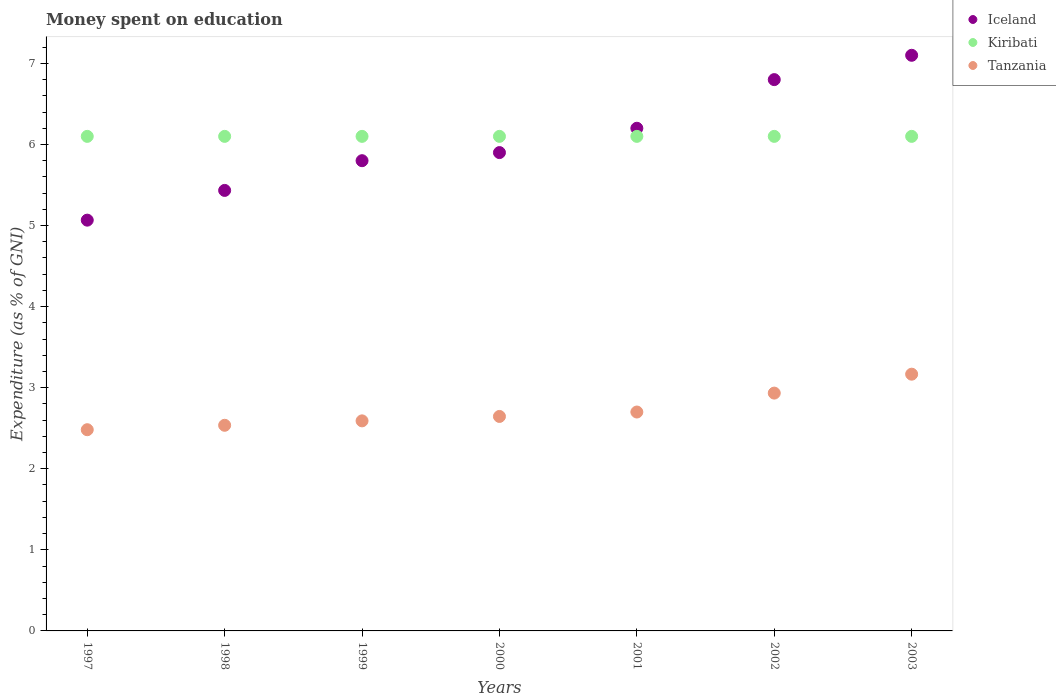How many different coloured dotlines are there?
Provide a succinct answer. 3. Is the number of dotlines equal to the number of legend labels?
Keep it short and to the point. Yes. Across all years, what is the maximum amount of money spent on education in Kiribati?
Offer a very short reply. 6.1. Across all years, what is the minimum amount of money spent on education in Tanzania?
Provide a short and direct response. 2.48. In which year was the amount of money spent on education in Kiribati maximum?
Provide a succinct answer. 1997. In which year was the amount of money spent on education in Kiribati minimum?
Ensure brevity in your answer.  1997. What is the total amount of money spent on education in Iceland in the graph?
Keep it short and to the point. 42.3. What is the difference between the amount of money spent on education in Tanzania in 1997 and that in 2001?
Make the answer very short. -0.22. What is the difference between the amount of money spent on education in Kiribati in 1998 and the amount of money spent on education in Tanzania in 2002?
Keep it short and to the point. 3.17. What is the average amount of money spent on education in Kiribati per year?
Make the answer very short. 6.1. In the year 2001, what is the difference between the amount of money spent on education in Kiribati and amount of money spent on education in Iceland?
Make the answer very short. -0.1. In how many years, is the amount of money spent on education in Tanzania greater than 1.4 %?
Provide a short and direct response. 7. What is the ratio of the amount of money spent on education in Iceland in 1998 to that in 2002?
Provide a short and direct response. 0.8. What is the difference between the highest and the second highest amount of money spent on education in Iceland?
Offer a terse response. 0.3. What is the difference between the highest and the lowest amount of money spent on education in Iceland?
Ensure brevity in your answer.  2.03. Is the sum of the amount of money spent on education in Iceland in 1998 and 2003 greater than the maximum amount of money spent on education in Kiribati across all years?
Offer a very short reply. Yes. Is it the case that in every year, the sum of the amount of money spent on education in Iceland and amount of money spent on education in Kiribati  is greater than the amount of money spent on education in Tanzania?
Ensure brevity in your answer.  Yes. How many dotlines are there?
Your response must be concise. 3. Does the graph contain any zero values?
Offer a very short reply. No. Does the graph contain grids?
Give a very brief answer. No. Where does the legend appear in the graph?
Your response must be concise. Top right. How are the legend labels stacked?
Provide a succinct answer. Vertical. What is the title of the graph?
Keep it short and to the point. Money spent on education. What is the label or title of the X-axis?
Keep it short and to the point. Years. What is the label or title of the Y-axis?
Your response must be concise. Expenditure (as % of GNI). What is the Expenditure (as % of GNI) of Iceland in 1997?
Make the answer very short. 5.07. What is the Expenditure (as % of GNI) of Kiribati in 1997?
Provide a short and direct response. 6.1. What is the Expenditure (as % of GNI) of Tanzania in 1997?
Provide a short and direct response. 2.48. What is the Expenditure (as % of GNI) in Iceland in 1998?
Offer a very short reply. 5.43. What is the Expenditure (as % of GNI) in Tanzania in 1998?
Keep it short and to the point. 2.54. What is the Expenditure (as % of GNI) of Kiribati in 1999?
Keep it short and to the point. 6.1. What is the Expenditure (as % of GNI) in Tanzania in 1999?
Ensure brevity in your answer.  2.59. What is the Expenditure (as % of GNI) in Kiribati in 2000?
Offer a very short reply. 6.1. What is the Expenditure (as % of GNI) in Tanzania in 2000?
Ensure brevity in your answer.  2.65. What is the Expenditure (as % of GNI) in Tanzania in 2001?
Your response must be concise. 2.7. What is the Expenditure (as % of GNI) in Iceland in 2002?
Keep it short and to the point. 6.8. What is the Expenditure (as % of GNI) of Kiribati in 2002?
Give a very brief answer. 6.1. What is the Expenditure (as % of GNI) of Tanzania in 2002?
Ensure brevity in your answer.  2.93. What is the Expenditure (as % of GNI) in Iceland in 2003?
Make the answer very short. 7.1. What is the Expenditure (as % of GNI) of Kiribati in 2003?
Keep it short and to the point. 6.1. What is the Expenditure (as % of GNI) of Tanzania in 2003?
Give a very brief answer. 3.17. Across all years, what is the maximum Expenditure (as % of GNI) in Iceland?
Keep it short and to the point. 7.1. Across all years, what is the maximum Expenditure (as % of GNI) in Kiribati?
Give a very brief answer. 6.1. Across all years, what is the maximum Expenditure (as % of GNI) in Tanzania?
Provide a short and direct response. 3.17. Across all years, what is the minimum Expenditure (as % of GNI) of Iceland?
Give a very brief answer. 5.07. Across all years, what is the minimum Expenditure (as % of GNI) of Kiribati?
Keep it short and to the point. 6.1. Across all years, what is the minimum Expenditure (as % of GNI) in Tanzania?
Offer a terse response. 2.48. What is the total Expenditure (as % of GNI) of Iceland in the graph?
Keep it short and to the point. 42.3. What is the total Expenditure (as % of GNI) in Kiribati in the graph?
Keep it short and to the point. 42.7. What is the total Expenditure (as % of GNI) in Tanzania in the graph?
Make the answer very short. 19.05. What is the difference between the Expenditure (as % of GNI) of Iceland in 1997 and that in 1998?
Provide a succinct answer. -0.37. What is the difference between the Expenditure (as % of GNI) of Kiribati in 1997 and that in 1998?
Offer a terse response. 0. What is the difference between the Expenditure (as % of GNI) in Tanzania in 1997 and that in 1998?
Ensure brevity in your answer.  -0.05. What is the difference between the Expenditure (as % of GNI) of Iceland in 1997 and that in 1999?
Your response must be concise. -0.73. What is the difference between the Expenditure (as % of GNI) in Kiribati in 1997 and that in 1999?
Your answer should be very brief. 0. What is the difference between the Expenditure (as % of GNI) in Tanzania in 1997 and that in 1999?
Ensure brevity in your answer.  -0.11. What is the difference between the Expenditure (as % of GNI) of Iceland in 1997 and that in 2000?
Offer a very short reply. -0.83. What is the difference between the Expenditure (as % of GNI) in Tanzania in 1997 and that in 2000?
Offer a terse response. -0.16. What is the difference between the Expenditure (as % of GNI) in Iceland in 1997 and that in 2001?
Your response must be concise. -1.13. What is the difference between the Expenditure (as % of GNI) in Tanzania in 1997 and that in 2001?
Give a very brief answer. -0.22. What is the difference between the Expenditure (as % of GNI) of Iceland in 1997 and that in 2002?
Make the answer very short. -1.73. What is the difference between the Expenditure (as % of GNI) of Kiribati in 1997 and that in 2002?
Your response must be concise. 0. What is the difference between the Expenditure (as % of GNI) in Tanzania in 1997 and that in 2002?
Keep it short and to the point. -0.45. What is the difference between the Expenditure (as % of GNI) in Iceland in 1997 and that in 2003?
Your answer should be very brief. -2.03. What is the difference between the Expenditure (as % of GNI) in Tanzania in 1997 and that in 2003?
Your answer should be compact. -0.68. What is the difference between the Expenditure (as % of GNI) of Iceland in 1998 and that in 1999?
Offer a terse response. -0.37. What is the difference between the Expenditure (as % of GNI) in Tanzania in 1998 and that in 1999?
Your response must be concise. -0.05. What is the difference between the Expenditure (as % of GNI) in Iceland in 1998 and that in 2000?
Provide a succinct answer. -0.47. What is the difference between the Expenditure (as % of GNI) in Kiribati in 1998 and that in 2000?
Ensure brevity in your answer.  0. What is the difference between the Expenditure (as % of GNI) of Tanzania in 1998 and that in 2000?
Provide a short and direct response. -0.11. What is the difference between the Expenditure (as % of GNI) in Iceland in 1998 and that in 2001?
Make the answer very short. -0.77. What is the difference between the Expenditure (as % of GNI) of Kiribati in 1998 and that in 2001?
Offer a very short reply. 0. What is the difference between the Expenditure (as % of GNI) in Tanzania in 1998 and that in 2001?
Your response must be concise. -0.16. What is the difference between the Expenditure (as % of GNI) in Iceland in 1998 and that in 2002?
Your response must be concise. -1.37. What is the difference between the Expenditure (as % of GNI) in Kiribati in 1998 and that in 2002?
Offer a very short reply. 0. What is the difference between the Expenditure (as % of GNI) in Tanzania in 1998 and that in 2002?
Keep it short and to the point. -0.4. What is the difference between the Expenditure (as % of GNI) of Iceland in 1998 and that in 2003?
Your answer should be compact. -1.67. What is the difference between the Expenditure (as % of GNI) of Kiribati in 1998 and that in 2003?
Ensure brevity in your answer.  0. What is the difference between the Expenditure (as % of GNI) of Tanzania in 1998 and that in 2003?
Keep it short and to the point. -0.63. What is the difference between the Expenditure (as % of GNI) in Iceland in 1999 and that in 2000?
Make the answer very short. -0.1. What is the difference between the Expenditure (as % of GNI) in Tanzania in 1999 and that in 2000?
Provide a short and direct response. -0.05. What is the difference between the Expenditure (as % of GNI) of Iceland in 1999 and that in 2001?
Give a very brief answer. -0.4. What is the difference between the Expenditure (as % of GNI) of Kiribati in 1999 and that in 2001?
Provide a short and direct response. 0. What is the difference between the Expenditure (as % of GNI) in Tanzania in 1999 and that in 2001?
Your answer should be compact. -0.11. What is the difference between the Expenditure (as % of GNI) of Iceland in 1999 and that in 2002?
Your response must be concise. -1. What is the difference between the Expenditure (as % of GNI) in Tanzania in 1999 and that in 2002?
Provide a short and direct response. -0.34. What is the difference between the Expenditure (as % of GNI) in Tanzania in 1999 and that in 2003?
Offer a terse response. -0.58. What is the difference between the Expenditure (as % of GNI) of Iceland in 2000 and that in 2001?
Your answer should be very brief. -0.3. What is the difference between the Expenditure (as % of GNI) in Kiribati in 2000 and that in 2001?
Give a very brief answer. 0. What is the difference between the Expenditure (as % of GNI) of Tanzania in 2000 and that in 2001?
Give a very brief answer. -0.05. What is the difference between the Expenditure (as % of GNI) in Kiribati in 2000 and that in 2002?
Keep it short and to the point. 0. What is the difference between the Expenditure (as % of GNI) in Tanzania in 2000 and that in 2002?
Your answer should be very brief. -0.29. What is the difference between the Expenditure (as % of GNI) in Kiribati in 2000 and that in 2003?
Give a very brief answer. 0. What is the difference between the Expenditure (as % of GNI) of Tanzania in 2000 and that in 2003?
Make the answer very short. -0.52. What is the difference between the Expenditure (as % of GNI) in Kiribati in 2001 and that in 2002?
Your answer should be compact. 0. What is the difference between the Expenditure (as % of GNI) in Tanzania in 2001 and that in 2002?
Keep it short and to the point. -0.23. What is the difference between the Expenditure (as % of GNI) in Iceland in 2001 and that in 2003?
Offer a very short reply. -0.9. What is the difference between the Expenditure (as % of GNI) in Tanzania in 2001 and that in 2003?
Provide a succinct answer. -0.47. What is the difference between the Expenditure (as % of GNI) in Kiribati in 2002 and that in 2003?
Keep it short and to the point. 0. What is the difference between the Expenditure (as % of GNI) of Tanzania in 2002 and that in 2003?
Give a very brief answer. -0.23. What is the difference between the Expenditure (as % of GNI) in Iceland in 1997 and the Expenditure (as % of GNI) in Kiribati in 1998?
Make the answer very short. -1.03. What is the difference between the Expenditure (as % of GNI) of Iceland in 1997 and the Expenditure (as % of GNI) of Tanzania in 1998?
Offer a terse response. 2.53. What is the difference between the Expenditure (as % of GNI) in Kiribati in 1997 and the Expenditure (as % of GNI) in Tanzania in 1998?
Offer a very short reply. 3.56. What is the difference between the Expenditure (as % of GNI) of Iceland in 1997 and the Expenditure (as % of GNI) of Kiribati in 1999?
Ensure brevity in your answer.  -1.03. What is the difference between the Expenditure (as % of GNI) of Iceland in 1997 and the Expenditure (as % of GNI) of Tanzania in 1999?
Ensure brevity in your answer.  2.48. What is the difference between the Expenditure (as % of GNI) of Kiribati in 1997 and the Expenditure (as % of GNI) of Tanzania in 1999?
Keep it short and to the point. 3.51. What is the difference between the Expenditure (as % of GNI) of Iceland in 1997 and the Expenditure (as % of GNI) of Kiribati in 2000?
Provide a succinct answer. -1.03. What is the difference between the Expenditure (as % of GNI) of Iceland in 1997 and the Expenditure (as % of GNI) of Tanzania in 2000?
Keep it short and to the point. 2.42. What is the difference between the Expenditure (as % of GNI) of Kiribati in 1997 and the Expenditure (as % of GNI) of Tanzania in 2000?
Give a very brief answer. 3.45. What is the difference between the Expenditure (as % of GNI) in Iceland in 1997 and the Expenditure (as % of GNI) in Kiribati in 2001?
Your answer should be very brief. -1.03. What is the difference between the Expenditure (as % of GNI) of Iceland in 1997 and the Expenditure (as % of GNI) of Tanzania in 2001?
Ensure brevity in your answer.  2.37. What is the difference between the Expenditure (as % of GNI) in Kiribati in 1997 and the Expenditure (as % of GNI) in Tanzania in 2001?
Give a very brief answer. 3.4. What is the difference between the Expenditure (as % of GNI) in Iceland in 1997 and the Expenditure (as % of GNI) in Kiribati in 2002?
Give a very brief answer. -1.03. What is the difference between the Expenditure (as % of GNI) in Iceland in 1997 and the Expenditure (as % of GNI) in Tanzania in 2002?
Keep it short and to the point. 2.13. What is the difference between the Expenditure (as % of GNI) in Kiribati in 1997 and the Expenditure (as % of GNI) in Tanzania in 2002?
Provide a short and direct response. 3.17. What is the difference between the Expenditure (as % of GNI) in Iceland in 1997 and the Expenditure (as % of GNI) in Kiribati in 2003?
Keep it short and to the point. -1.03. What is the difference between the Expenditure (as % of GNI) in Kiribati in 1997 and the Expenditure (as % of GNI) in Tanzania in 2003?
Ensure brevity in your answer.  2.93. What is the difference between the Expenditure (as % of GNI) of Iceland in 1998 and the Expenditure (as % of GNI) of Kiribati in 1999?
Offer a very short reply. -0.67. What is the difference between the Expenditure (as % of GNI) of Iceland in 1998 and the Expenditure (as % of GNI) of Tanzania in 1999?
Offer a very short reply. 2.84. What is the difference between the Expenditure (as % of GNI) of Kiribati in 1998 and the Expenditure (as % of GNI) of Tanzania in 1999?
Make the answer very short. 3.51. What is the difference between the Expenditure (as % of GNI) in Iceland in 1998 and the Expenditure (as % of GNI) in Tanzania in 2000?
Ensure brevity in your answer.  2.79. What is the difference between the Expenditure (as % of GNI) in Kiribati in 1998 and the Expenditure (as % of GNI) in Tanzania in 2000?
Your answer should be very brief. 3.45. What is the difference between the Expenditure (as % of GNI) of Iceland in 1998 and the Expenditure (as % of GNI) of Tanzania in 2001?
Your response must be concise. 2.73. What is the difference between the Expenditure (as % of GNI) of Kiribati in 1998 and the Expenditure (as % of GNI) of Tanzania in 2001?
Ensure brevity in your answer.  3.4. What is the difference between the Expenditure (as % of GNI) of Iceland in 1998 and the Expenditure (as % of GNI) of Kiribati in 2002?
Provide a short and direct response. -0.67. What is the difference between the Expenditure (as % of GNI) of Iceland in 1998 and the Expenditure (as % of GNI) of Tanzania in 2002?
Offer a terse response. 2.5. What is the difference between the Expenditure (as % of GNI) of Kiribati in 1998 and the Expenditure (as % of GNI) of Tanzania in 2002?
Your answer should be compact. 3.17. What is the difference between the Expenditure (as % of GNI) of Iceland in 1998 and the Expenditure (as % of GNI) of Kiribati in 2003?
Give a very brief answer. -0.67. What is the difference between the Expenditure (as % of GNI) in Iceland in 1998 and the Expenditure (as % of GNI) in Tanzania in 2003?
Keep it short and to the point. 2.27. What is the difference between the Expenditure (as % of GNI) of Kiribati in 1998 and the Expenditure (as % of GNI) of Tanzania in 2003?
Provide a succinct answer. 2.93. What is the difference between the Expenditure (as % of GNI) of Iceland in 1999 and the Expenditure (as % of GNI) of Tanzania in 2000?
Your response must be concise. 3.15. What is the difference between the Expenditure (as % of GNI) of Kiribati in 1999 and the Expenditure (as % of GNI) of Tanzania in 2000?
Offer a very short reply. 3.45. What is the difference between the Expenditure (as % of GNI) of Iceland in 1999 and the Expenditure (as % of GNI) of Kiribati in 2002?
Your answer should be compact. -0.3. What is the difference between the Expenditure (as % of GNI) of Iceland in 1999 and the Expenditure (as % of GNI) of Tanzania in 2002?
Give a very brief answer. 2.87. What is the difference between the Expenditure (as % of GNI) of Kiribati in 1999 and the Expenditure (as % of GNI) of Tanzania in 2002?
Your answer should be compact. 3.17. What is the difference between the Expenditure (as % of GNI) in Iceland in 1999 and the Expenditure (as % of GNI) in Tanzania in 2003?
Offer a terse response. 2.63. What is the difference between the Expenditure (as % of GNI) of Kiribati in 1999 and the Expenditure (as % of GNI) of Tanzania in 2003?
Your answer should be very brief. 2.93. What is the difference between the Expenditure (as % of GNI) in Iceland in 2000 and the Expenditure (as % of GNI) in Kiribati in 2001?
Your answer should be very brief. -0.2. What is the difference between the Expenditure (as % of GNI) of Iceland in 2000 and the Expenditure (as % of GNI) of Tanzania in 2001?
Keep it short and to the point. 3.2. What is the difference between the Expenditure (as % of GNI) of Kiribati in 2000 and the Expenditure (as % of GNI) of Tanzania in 2001?
Give a very brief answer. 3.4. What is the difference between the Expenditure (as % of GNI) in Iceland in 2000 and the Expenditure (as % of GNI) in Kiribati in 2002?
Give a very brief answer. -0.2. What is the difference between the Expenditure (as % of GNI) in Iceland in 2000 and the Expenditure (as % of GNI) in Tanzania in 2002?
Give a very brief answer. 2.97. What is the difference between the Expenditure (as % of GNI) in Kiribati in 2000 and the Expenditure (as % of GNI) in Tanzania in 2002?
Offer a terse response. 3.17. What is the difference between the Expenditure (as % of GNI) in Iceland in 2000 and the Expenditure (as % of GNI) in Kiribati in 2003?
Offer a terse response. -0.2. What is the difference between the Expenditure (as % of GNI) in Iceland in 2000 and the Expenditure (as % of GNI) in Tanzania in 2003?
Make the answer very short. 2.73. What is the difference between the Expenditure (as % of GNI) of Kiribati in 2000 and the Expenditure (as % of GNI) of Tanzania in 2003?
Your answer should be very brief. 2.93. What is the difference between the Expenditure (as % of GNI) in Iceland in 2001 and the Expenditure (as % of GNI) in Kiribati in 2002?
Ensure brevity in your answer.  0.1. What is the difference between the Expenditure (as % of GNI) of Iceland in 2001 and the Expenditure (as % of GNI) of Tanzania in 2002?
Offer a terse response. 3.27. What is the difference between the Expenditure (as % of GNI) of Kiribati in 2001 and the Expenditure (as % of GNI) of Tanzania in 2002?
Provide a short and direct response. 3.17. What is the difference between the Expenditure (as % of GNI) in Iceland in 2001 and the Expenditure (as % of GNI) in Kiribati in 2003?
Make the answer very short. 0.1. What is the difference between the Expenditure (as % of GNI) in Iceland in 2001 and the Expenditure (as % of GNI) in Tanzania in 2003?
Ensure brevity in your answer.  3.03. What is the difference between the Expenditure (as % of GNI) in Kiribati in 2001 and the Expenditure (as % of GNI) in Tanzania in 2003?
Make the answer very short. 2.93. What is the difference between the Expenditure (as % of GNI) of Iceland in 2002 and the Expenditure (as % of GNI) of Tanzania in 2003?
Provide a short and direct response. 3.63. What is the difference between the Expenditure (as % of GNI) in Kiribati in 2002 and the Expenditure (as % of GNI) in Tanzania in 2003?
Keep it short and to the point. 2.93. What is the average Expenditure (as % of GNI) in Iceland per year?
Offer a very short reply. 6.04. What is the average Expenditure (as % of GNI) in Kiribati per year?
Make the answer very short. 6.1. What is the average Expenditure (as % of GNI) of Tanzania per year?
Make the answer very short. 2.72. In the year 1997, what is the difference between the Expenditure (as % of GNI) in Iceland and Expenditure (as % of GNI) in Kiribati?
Keep it short and to the point. -1.03. In the year 1997, what is the difference between the Expenditure (as % of GNI) in Iceland and Expenditure (as % of GNI) in Tanzania?
Keep it short and to the point. 2.58. In the year 1997, what is the difference between the Expenditure (as % of GNI) in Kiribati and Expenditure (as % of GNI) in Tanzania?
Keep it short and to the point. 3.62. In the year 1998, what is the difference between the Expenditure (as % of GNI) in Iceland and Expenditure (as % of GNI) in Kiribati?
Make the answer very short. -0.67. In the year 1998, what is the difference between the Expenditure (as % of GNI) of Iceland and Expenditure (as % of GNI) of Tanzania?
Ensure brevity in your answer.  2.9. In the year 1998, what is the difference between the Expenditure (as % of GNI) in Kiribati and Expenditure (as % of GNI) in Tanzania?
Make the answer very short. 3.56. In the year 1999, what is the difference between the Expenditure (as % of GNI) in Iceland and Expenditure (as % of GNI) in Kiribati?
Offer a very short reply. -0.3. In the year 1999, what is the difference between the Expenditure (as % of GNI) of Iceland and Expenditure (as % of GNI) of Tanzania?
Give a very brief answer. 3.21. In the year 1999, what is the difference between the Expenditure (as % of GNI) of Kiribati and Expenditure (as % of GNI) of Tanzania?
Ensure brevity in your answer.  3.51. In the year 2000, what is the difference between the Expenditure (as % of GNI) in Iceland and Expenditure (as % of GNI) in Tanzania?
Provide a short and direct response. 3.25. In the year 2000, what is the difference between the Expenditure (as % of GNI) of Kiribati and Expenditure (as % of GNI) of Tanzania?
Make the answer very short. 3.45. In the year 2001, what is the difference between the Expenditure (as % of GNI) in Iceland and Expenditure (as % of GNI) in Kiribati?
Offer a terse response. 0.1. In the year 2002, what is the difference between the Expenditure (as % of GNI) of Iceland and Expenditure (as % of GNI) of Kiribati?
Your answer should be compact. 0.7. In the year 2002, what is the difference between the Expenditure (as % of GNI) of Iceland and Expenditure (as % of GNI) of Tanzania?
Your answer should be very brief. 3.87. In the year 2002, what is the difference between the Expenditure (as % of GNI) of Kiribati and Expenditure (as % of GNI) of Tanzania?
Make the answer very short. 3.17. In the year 2003, what is the difference between the Expenditure (as % of GNI) in Iceland and Expenditure (as % of GNI) in Tanzania?
Your response must be concise. 3.93. In the year 2003, what is the difference between the Expenditure (as % of GNI) of Kiribati and Expenditure (as % of GNI) of Tanzania?
Ensure brevity in your answer.  2.93. What is the ratio of the Expenditure (as % of GNI) in Iceland in 1997 to that in 1998?
Make the answer very short. 0.93. What is the ratio of the Expenditure (as % of GNI) in Kiribati in 1997 to that in 1998?
Offer a very short reply. 1. What is the ratio of the Expenditure (as % of GNI) of Tanzania in 1997 to that in 1998?
Your answer should be compact. 0.98. What is the ratio of the Expenditure (as % of GNI) of Iceland in 1997 to that in 1999?
Keep it short and to the point. 0.87. What is the ratio of the Expenditure (as % of GNI) in Kiribati in 1997 to that in 1999?
Provide a short and direct response. 1. What is the ratio of the Expenditure (as % of GNI) of Tanzania in 1997 to that in 1999?
Provide a succinct answer. 0.96. What is the ratio of the Expenditure (as % of GNI) of Iceland in 1997 to that in 2000?
Keep it short and to the point. 0.86. What is the ratio of the Expenditure (as % of GNI) of Tanzania in 1997 to that in 2000?
Keep it short and to the point. 0.94. What is the ratio of the Expenditure (as % of GNI) of Iceland in 1997 to that in 2001?
Offer a very short reply. 0.82. What is the ratio of the Expenditure (as % of GNI) of Tanzania in 1997 to that in 2001?
Make the answer very short. 0.92. What is the ratio of the Expenditure (as % of GNI) in Iceland in 1997 to that in 2002?
Offer a very short reply. 0.75. What is the ratio of the Expenditure (as % of GNI) of Kiribati in 1997 to that in 2002?
Your answer should be compact. 1. What is the ratio of the Expenditure (as % of GNI) in Tanzania in 1997 to that in 2002?
Your response must be concise. 0.85. What is the ratio of the Expenditure (as % of GNI) in Iceland in 1997 to that in 2003?
Keep it short and to the point. 0.71. What is the ratio of the Expenditure (as % of GNI) in Kiribati in 1997 to that in 2003?
Ensure brevity in your answer.  1. What is the ratio of the Expenditure (as % of GNI) of Tanzania in 1997 to that in 2003?
Offer a terse response. 0.78. What is the ratio of the Expenditure (as % of GNI) in Iceland in 1998 to that in 1999?
Give a very brief answer. 0.94. What is the ratio of the Expenditure (as % of GNI) of Tanzania in 1998 to that in 1999?
Offer a terse response. 0.98. What is the ratio of the Expenditure (as % of GNI) in Iceland in 1998 to that in 2000?
Provide a short and direct response. 0.92. What is the ratio of the Expenditure (as % of GNI) of Tanzania in 1998 to that in 2000?
Provide a short and direct response. 0.96. What is the ratio of the Expenditure (as % of GNI) in Iceland in 1998 to that in 2001?
Provide a succinct answer. 0.88. What is the ratio of the Expenditure (as % of GNI) in Kiribati in 1998 to that in 2001?
Provide a succinct answer. 1. What is the ratio of the Expenditure (as % of GNI) of Tanzania in 1998 to that in 2001?
Ensure brevity in your answer.  0.94. What is the ratio of the Expenditure (as % of GNI) in Iceland in 1998 to that in 2002?
Your response must be concise. 0.8. What is the ratio of the Expenditure (as % of GNI) of Tanzania in 1998 to that in 2002?
Ensure brevity in your answer.  0.86. What is the ratio of the Expenditure (as % of GNI) in Iceland in 1998 to that in 2003?
Keep it short and to the point. 0.77. What is the ratio of the Expenditure (as % of GNI) in Kiribati in 1998 to that in 2003?
Your response must be concise. 1. What is the ratio of the Expenditure (as % of GNI) of Tanzania in 1998 to that in 2003?
Your answer should be compact. 0.8. What is the ratio of the Expenditure (as % of GNI) in Iceland in 1999 to that in 2000?
Give a very brief answer. 0.98. What is the ratio of the Expenditure (as % of GNI) of Tanzania in 1999 to that in 2000?
Make the answer very short. 0.98. What is the ratio of the Expenditure (as % of GNI) of Iceland in 1999 to that in 2001?
Provide a succinct answer. 0.94. What is the ratio of the Expenditure (as % of GNI) of Kiribati in 1999 to that in 2001?
Offer a very short reply. 1. What is the ratio of the Expenditure (as % of GNI) of Tanzania in 1999 to that in 2001?
Make the answer very short. 0.96. What is the ratio of the Expenditure (as % of GNI) of Iceland in 1999 to that in 2002?
Provide a succinct answer. 0.85. What is the ratio of the Expenditure (as % of GNI) in Kiribati in 1999 to that in 2002?
Your answer should be very brief. 1. What is the ratio of the Expenditure (as % of GNI) of Tanzania in 1999 to that in 2002?
Provide a short and direct response. 0.88. What is the ratio of the Expenditure (as % of GNI) in Iceland in 1999 to that in 2003?
Provide a succinct answer. 0.82. What is the ratio of the Expenditure (as % of GNI) in Kiribati in 1999 to that in 2003?
Your answer should be very brief. 1. What is the ratio of the Expenditure (as % of GNI) in Tanzania in 1999 to that in 2003?
Give a very brief answer. 0.82. What is the ratio of the Expenditure (as % of GNI) of Iceland in 2000 to that in 2001?
Provide a short and direct response. 0.95. What is the ratio of the Expenditure (as % of GNI) in Kiribati in 2000 to that in 2001?
Offer a terse response. 1. What is the ratio of the Expenditure (as % of GNI) in Tanzania in 2000 to that in 2001?
Offer a very short reply. 0.98. What is the ratio of the Expenditure (as % of GNI) of Iceland in 2000 to that in 2002?
Your answer should be very brief. 0.87. What is the ratio of the Expenditure (as % of GNI) in Kiribati in 2000 to that in 2002?
Offer a terse response. 1. What is the ratio of the Expenditure (as % of GNI) of Tanzania in 2000 to that in 2002?
Keep it short and to the point. 0.9. What is the ratio of the Expenditure (as % of GNI) of Iceland in 2000 to that in 2003?
Your response must be concise. 0.83. What is the ratio of the Expenditure (as % of GNI) of Kiribati in 2000 to that in 2003?
Provide a short and direct response. 1. What is the ratio of the Expenditure (as % of GNI) of Tanzania in 2000 to that in 2003?
Provide a short and direct response. 0.84. What is the ratio of the Expenditure (as % of GNI) of Iceland in 2001 to that in 2002?
Your answer should be compact. 0.91. What is the ratio of the Expenditure (as % of GNI) in Kiribati in 2001 to that in 2002?
Make the answer very short. 1. What is the ratio of the Expenditure (as % of GNI) of Tanzania in 2001 to that in 2002?
Keep it short and to the point. 0.92. What is the ratio of the Expenditure (as % of GNI) in Iceland in 2001 to that in 2003?
Make the answer very short. 0.87. What is the ratio of the Expenditure (as % of GNI) in Tanzania in 2001 to that in 2003?
Make the answer very short. 0.85. What is the ratio of the Expenditure (as % of GNI) in Iceland in 2002 to that in 2003?
Your response must be concise. 0.96. What is the ratio of the Expenditure (as % of GNI) of Kiribati in 2002 to that in 2003?
Your response must be concise. 1. What is the ratio of the Expenditure (as % of GNI) in Tanzania in 2002 to that in 2003?
Make the answer very short. 0.93. What is the difference between the highest and the second highest Expenditure (as % of GNI) of Iceland?
Provide a succinct answer. 0.3. What is the difference between the highest and the second highest Expenditure (as % of GNI) in Kiribati?
Offer a terse response. 0. What is the difference between the highest and the second highest Expenditure (as % of GNI) of Tanzania?
Offer a terse response. 0.23. What is the difference between the highest and the lowest Expenditure (as % of GNI) in Iceland?
Your response must be concise. 2.03. What is the difference between the highest and the lowest Expenditure (as % of GNI) in Tanzania?
Provide a succinct answer. 0.68. 